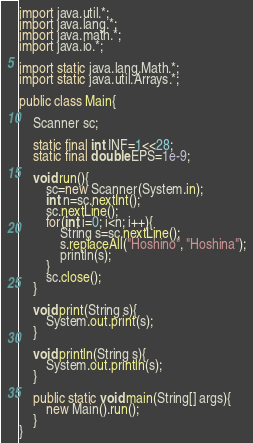<code> <loc_0><loc_0><loc_500><loc_500><_Java_>import java.util.*;
import java.lang.*;
import java.math.*;
import java.io.*;

import static java.lang.Math.*;
import static java.util.Arrays.*;

public class Main{

	Scanner sc;

	static final int INF=1<<28;
	static final double EPS=1e-9;

	void run(){
		sc=new Scanner(System.in);
		int n=sc.nextInt();
		sc.nextLine();
		for(int i=0; i<n; i++){
			String s=sc.nextLine();
			s.replaceAll("Hoshino", "Hoshina");
			println(s);
		}
		sc.close();
	}

	void print(String s){
		System.out.print(s);
	}

	void println(String s){
		System.out.println(s);
	}

	public static void main(String[] args){
		new Main().run();
	}
}</code> 